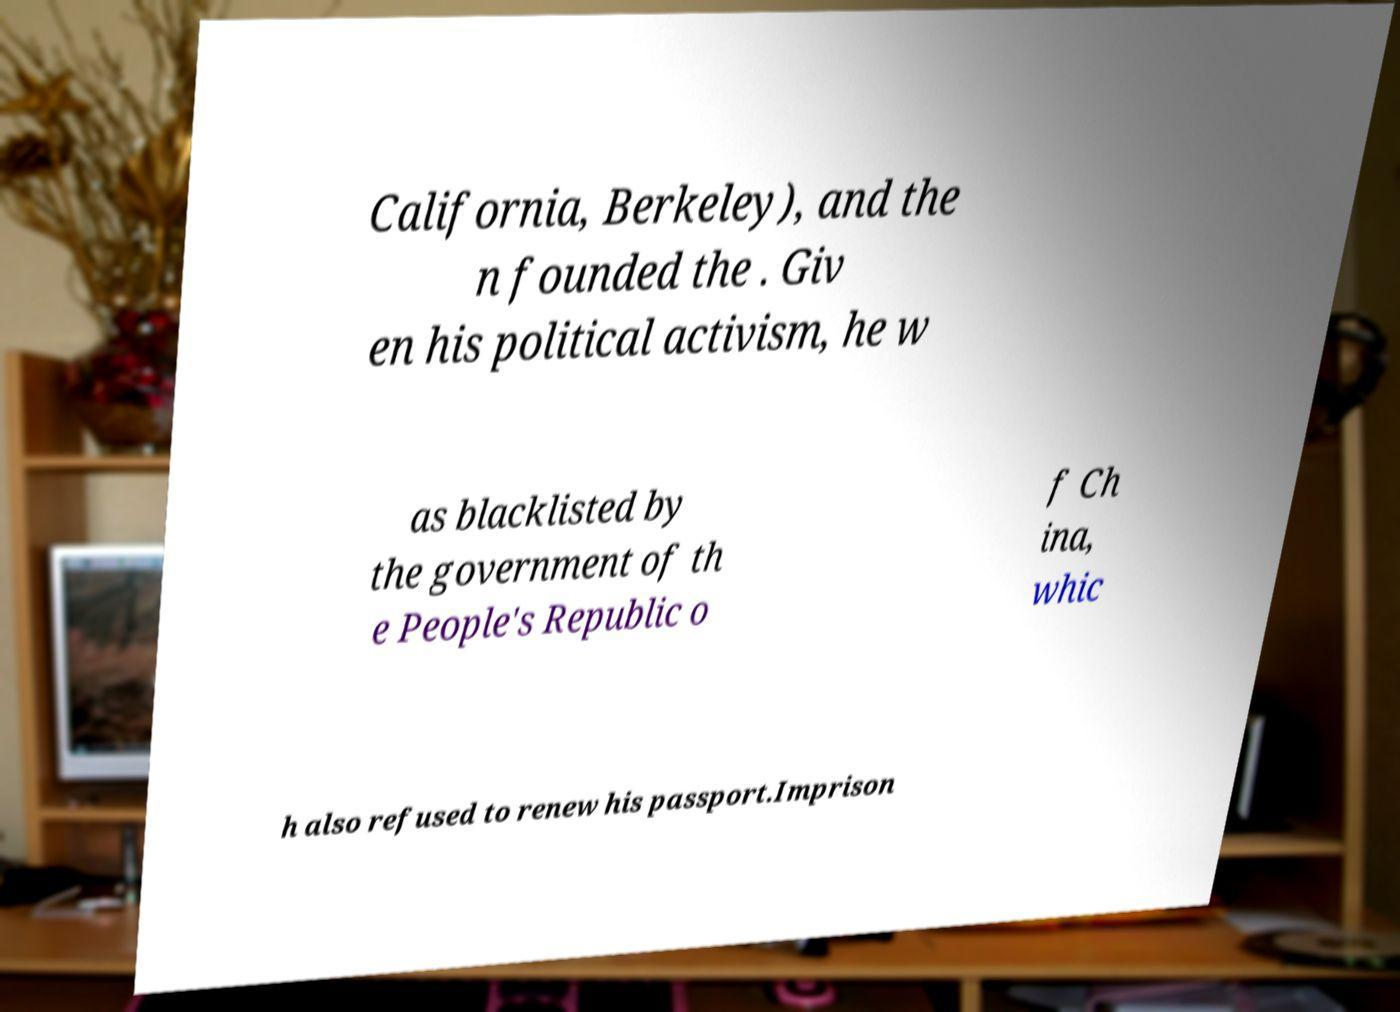Can you accurately transcribe the text from the provided image for me? California, Berkeley), and the n founded the . Giv en his political activism, he w as blacklisted by the government of th e People's Republic o f Ch ina, whic h also refused to renew his passport.Imprison 